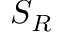<formula> <loc_0><loc_0><loc_500><loc_500>S _ { R }</formula> 